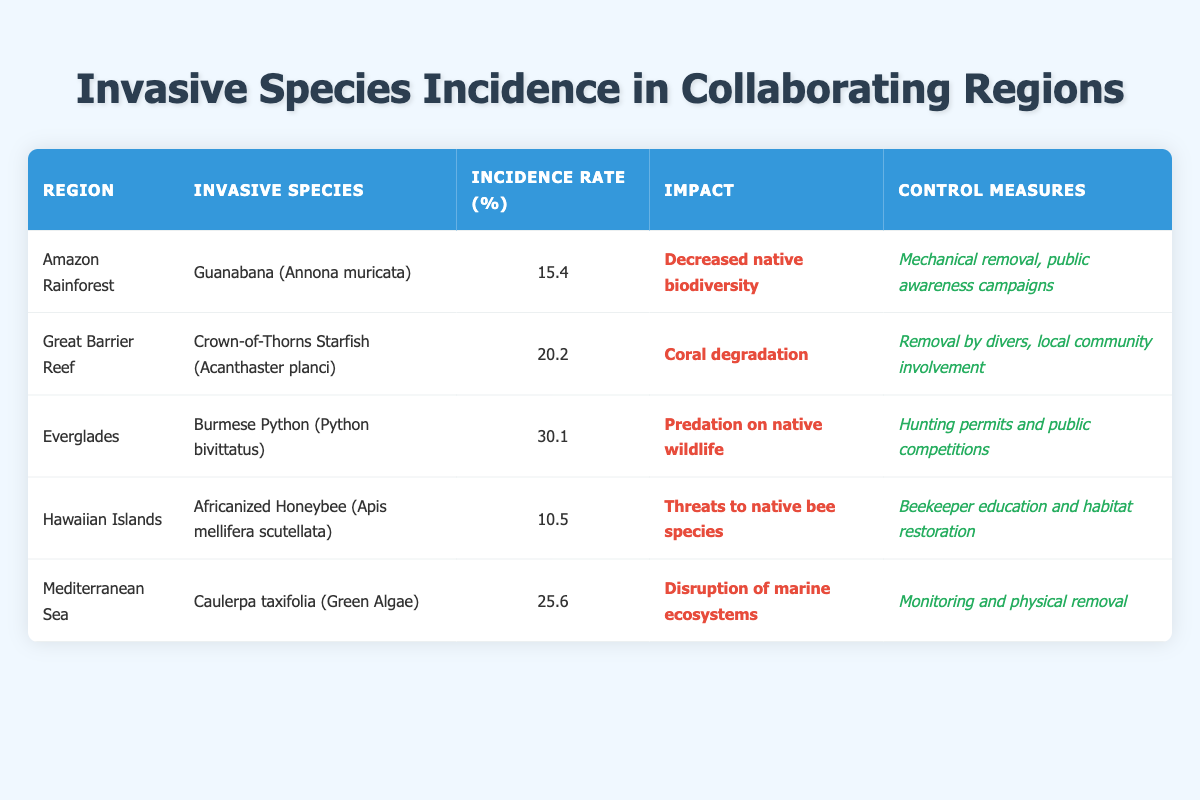What is the incidence rate of the Burmese Python in the Everglades? According to the table, the incidence rate for the Burmese Python (Python bivittatus) in the Everglades is specifically listed under the "Incidence Rate" column, where it shows 30.1.
Answer: 30.1 Which region has the highest incidence rate of invasive species? By reviewing the "Incidence Rate (%)" column in the table, the highest value is 30.1 for the Everglades, hence that region has the highest incidence rate.
Answer: Everglades Is mechanical removal mentioned as a control measure for any invasive species? Looking through the "Control Measures" column, mechanical removal is cited for the Guanabana (Annona muricata) in the Amazon Rainforest. Therefore, the answer is yes.
Answer: Yes What is the average incidence rate of invasive species in the regions listed? To find the average incidence rate, we first sum the incidence rates: 15.4 + 20.2 + 30.1 + 10.5 + 25.6 = 101.8. There are 5 regions, so the average is 101.8/5 = 20.36.
Answer: 20.36 Does the Africanized Honeybee pose a threat to native species? The table indicates that the impact of the Africanized Honeybee (Apis mellifera scutellata) is to pose threats to native bee species, confirming this fact.
Answer: Yes Which invasive species has the lowest incidence rate and what is that rate? By comparing the "Incidence Rate (%)" column, the Africanized Honeybee (Apis mellifera scutellata) has the lowest incidence rate at 10.5.
Answer: Africanized Honeybee (10.5) What control measures were taken for the Crown-of-Thorns Starfish in the Great Barrier Reef? In the "Control Measures" column for the Great Barrier Reef, it mentions removal by divers and local community involvement as the control measures for the Crown-of-Thorns Starfish (Acanthaster planci).
Answer: Removal by divers, local community involvement How many invasive species that disrupt marine ecosystems are listed, and what are their names? Two entries in the table relate to marine ecosystems. The Mediterranean Sea lists Caulerpa taxifolia that disrupts marine ecosystems, while the Great Barrier Reef lists coral degradation, although it's not specified as an invasive species directly disrupting marine ecosystems. Thus, only Caulerpa taxifolia qualifies.
Answer: 1 (Caulerpa taxifolia) Which region's invasive species has the highest documented impact? The highest impact recorded is for the Burmese Python (Python bivittatus) in the Everglades, which mentions predation on native wildlife. This requires understanding which impacts are severe. Considering "degradation" is broader, the Burmese Python's impact here is significant.
Answer: Everglades (Burmese Python) 